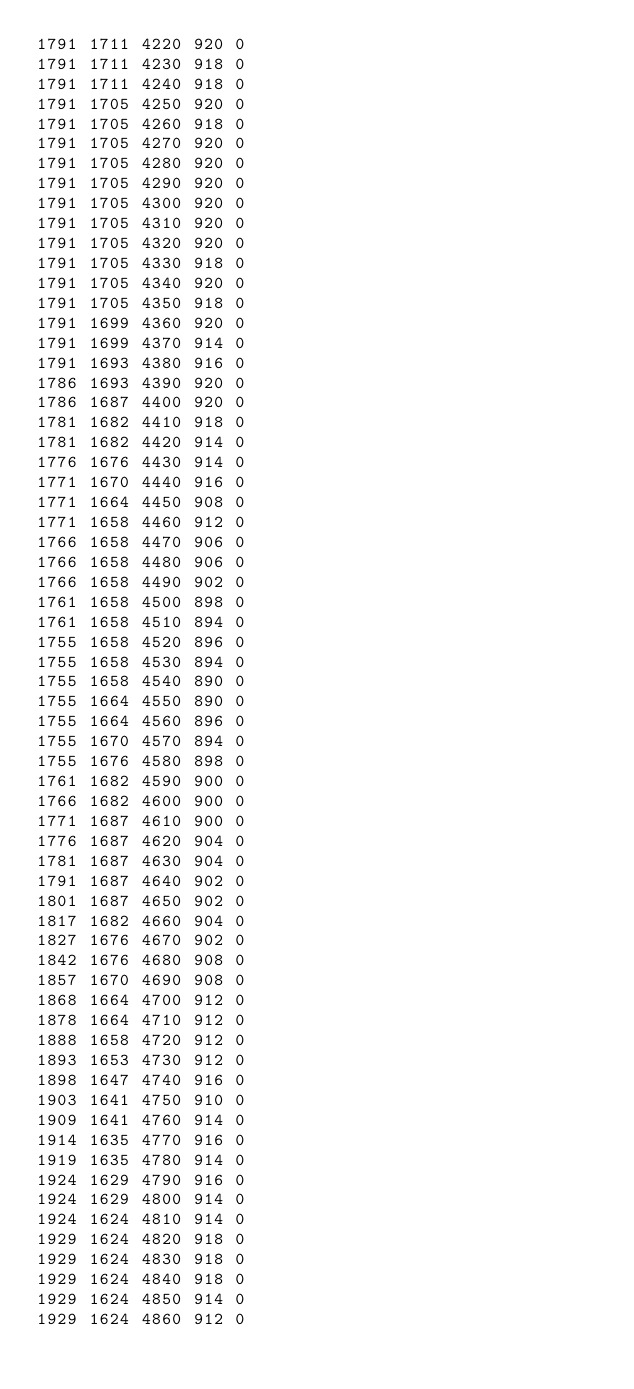Convert code to text. <code><loc_0><loc_0><loc_500><loc_500><_SML_>1791 1711 4220 920 0
1791 1711 4230 918 0
1791 1711 4240 918 0
1791 1705 4250 920 0
1791 1705 4260 918 0
1791 1705 4270 920 0
1791 1705 4280 920 0
1791 1705 4290 920 0
1791 1705 4300 920 0
1791 1705 4310 920 0
1791 1705 4320 920 0
1791 1705 4330 918 0
1791 1705 4340 920 0
1791 1705 4350 918 0
1791 1699 4360 920 0
1791 1699 4370 914 0
1791 1693 4380 916 0
1786 1693 4390 920 0
1786 1687 4400 920 0
1781 1682 4410 918 0
1781 1682 4420 914 0
1776 1676 4430 914 0
1771 1670 4440 916 0
1771 1664 4450 908 0
1771 1658 4460 912 0
1766 1658 4470 906 0
1766 1658 4480 906 0
1766 1658 4490 902 0
1761 1658 4500 898 0
1761 1658 4510 894 0
1755 1658 4520 896 0
1755 1658 4530 894 0
1755 1658 4540 890 0
1755 1664 4550 890 0
1755 1664 4560 896 0
1755 1670 4570 894 0
1755 1676 4580 898 0
1761 1682 4590 900 0
1766 1682 4600 900 0
1771 1687 4610 900 0
1776 1687 4620 904 0
1781 1687 4630 904 0
1791 1687 4640 902 0
1801 1687 4650 902 0
1817 1682 4660 904 0
1827 1676 4670 902 0
1842 1676 4680 908 0
1857 1670 4690 908 0
1868 1664 4700 912 0
1878 1664 4710 912 0
1888 1658 4720 912 0
1893 1653 4730 912 0
1898 1647 4740 916 0
1903 1641 4750 910 0
1909 1641 4760 914 0
1914 1635 4770 916 0
1919 1635 4780 914 0
1924 1629 4790 916 0
1924 1629 4800 914 0
1924 1624 4810 914 0
1929 1624 4820 918 0
1929 1624 4830 918 0
1929 1624 4840 918 0
1929 1624 4850 914 0
1929 1624 4860 912 0</code> 